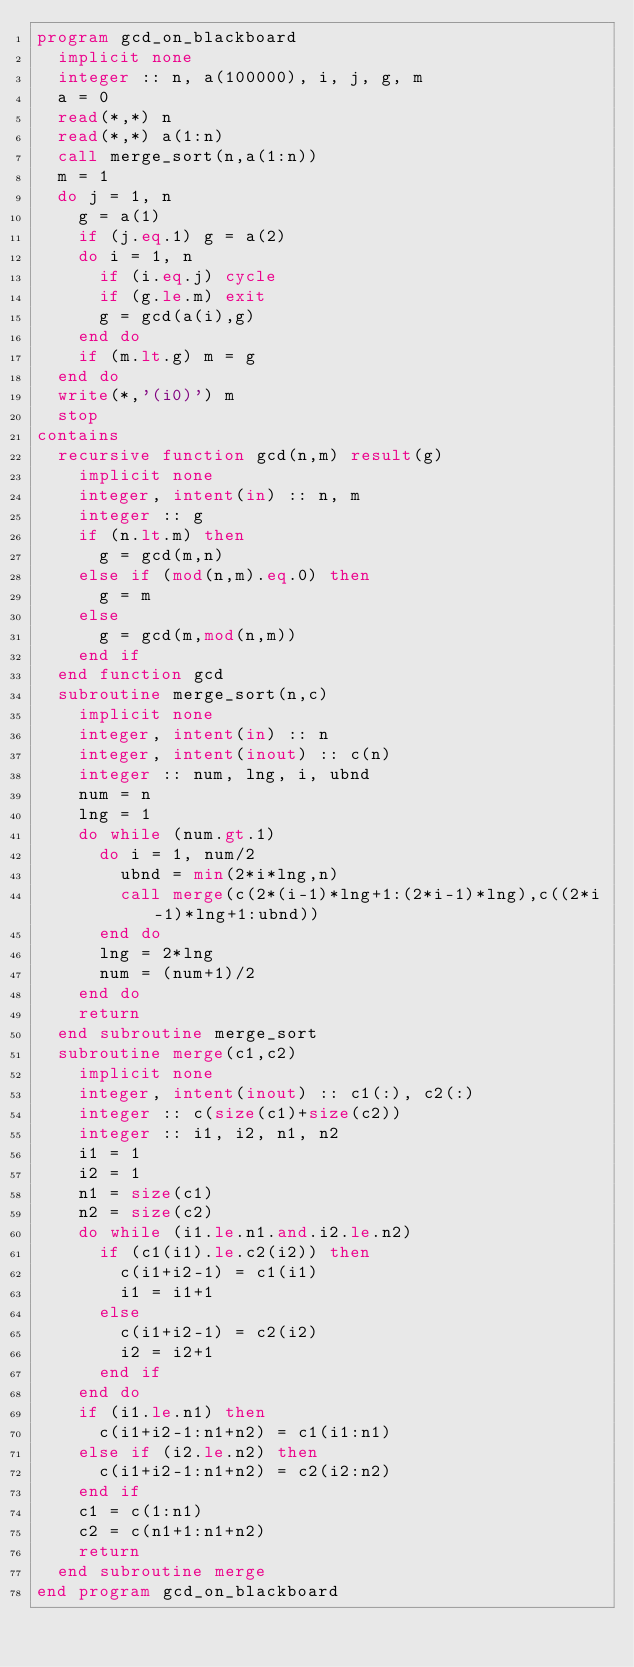<code> <loc_0><loc_0><loc_500><loc_500><_FORTRAN_>program gcd_on_blackboard
  implicit none
  integer :: n, a(100000), i, j, g, m
  a = 0
  read(*,*) n
  read(*,*) a(1:n)
  call merge_sort(n,a(1:n))
  m = 1
  do j = 1, n
    g = a(1)
    if (j.eq.1) g = a(2)
    do i = 1, n
      if (i.eq.j) cycle
      if (g.le.m) exit
      g = gcd(a(i),g)
    end do
    if (m.lt.g) m = g
  end do
  write(*,'(i0)') m
  stop
contains
  recursive function gcd(n,m) result(g)
    implicit none
    integer, intent(in) :: n, m
    integer :: g
    if (n.lt.m) then
      g = gcd(m,n)
    else if (mod(n,m).eq.0) then
      g = m
    else
      g = gcd(m,mod(n,m))
    end if
  end function gcd
  subroutine merge_sort(n,c)
    implicit none
    integer, intent(in) :: n
    integer, intent(inout) :: c(n)
    integer :: num, lng, i, ubnd
    num = n
    lng = 1
    do while (num.gt.1)
      do i = 1, num/2
        ubnd = min(2*i*lng,n)
        call merge(c(2*(i-1)*lng+1:(2*i-1)*lng),c((2*i-1)*lng+1:ubnd))
      end do
      lng = 2*lng
      num = (num+1)/2
    end do
    return
  end subroutine merge_sort
  subroutine merge(c1,c2)
    implicit none
    integer, intent(inout) :: c1(:), c2(:)
    integer :: c(size(c1)+size(c2))
    integer :: i1, i2, n1, n2
    i1 = 1
    i2 = 1
    n1 = size(c1)
    n2 = size(c2)
    do while (i1.le.n1.and.i2.le.n2)
      if (c1(i1).le.c2(i2)) then
        c(i1+i2-1) = c1(i1)
        i1 = i1+1
      else
        c(i1+i2-1) = c2(i2)
        i2 = i2+1
      end if
    end do
    if (i1.le.n1) then
      c(i1+i2-1:n1+n2) = c1(i1:n1)
    else if (i2.le.n2) then
      c(i1+i2-1:n1+n2) = c2(i2:n2)
    end if
    c1 = c(1:n1)
    c2 = c(n1+1:n1+n2)
    return
  end subroutine merge
end program gcd_on_blackboard</code> 